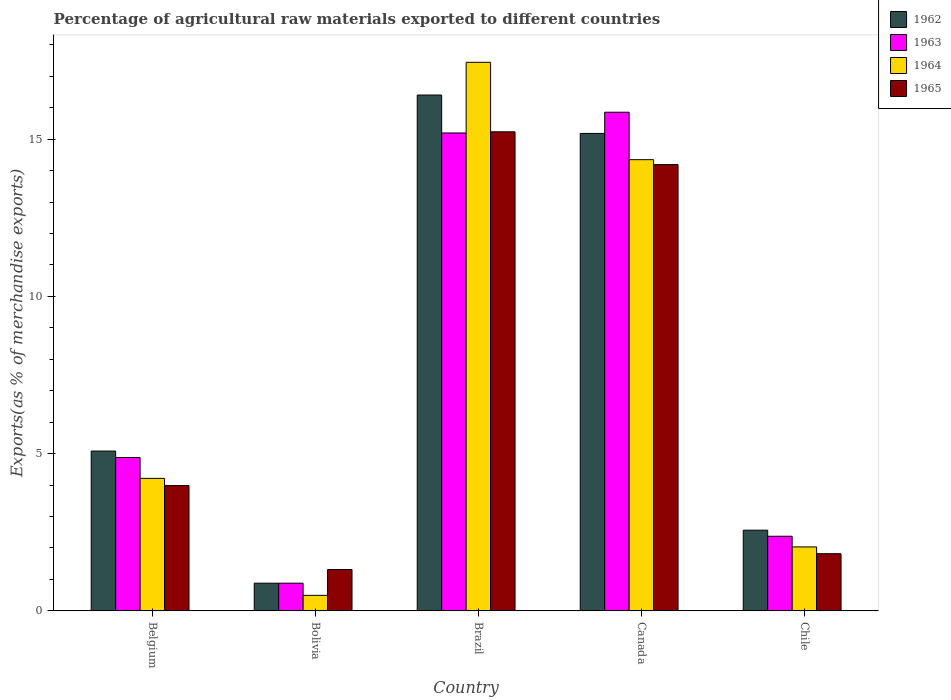How many groups of bars are there?
Provide a succinct answer. 5. Are the number of bars on each tick of the X-axis equal?
Offer a terse response. Yes. How many bars are there on the 3rd tick from the left?
Keep it short and to the point. 4. What is the percentage of exports to different countries in 1962 in Canada?
Keep it short and to the point. 15.18. Across all countries, what is the maximum percentage of exports to different countries in 1963?
Keep it short and to the point. 15.85. Across all countries, what is the minimum percentage of exports to different countries in 1964?
Your response must be concise. 0.49. In which country was the percentage of exports to different countries in 1962 maximum?
Offer a terse response. Brazil. What is the total percentage of exports to different countries in 1962 in the graph?
Make the answer very short. 40.11. What is the difference between the percentage of exports to different countries in 1963 in Belgium and that in Chile?
Your answer should be very brief. 2.5. What is the difference between the percentage of exports to different countries in 1963 in Bolivia and the percentage of exports to different countries in 1962 in Brazil?
Provide a short and direct response. -15.52. What is the average percentage of exports to different countries in 1964 per country?
Make the answer very short. 7.71. What is the difference between the percentage of exports to different countries of/in 1962 and percentage of exports to different countries of/in 1965 in Bolivia?
Your answer should be very brief. -0.43. What is the ratio of the percentage of exports to different countries in 1963 in Bolivia to that in Brazil?
Provide a succinct answer. 0.06. Is the percentage of exports to different countries in 1963 in Belgium less than that in Brazil?
Your answer should be very brief. Yes. Is the difference between the percentage of exports to different countries in 1962 in Bolivia and Canada greater than the difference between the percentage of exports to different countries in 1965 in Bolivia and Canada?
Offer a very short reply. No. What is the difference between the highest and the second highest percentage of exports to different countries in 1963?
Give a very brief answer. 10.32. What is the difference between the highest and the lowest percentage of exports to different countries in 1962?
Your response must be concise. 15.52. Is the sum of the percentage of exports to different countries in 1962 in Canada and Chile greater than the maximum percentage of exports to different countries in 1963 across all countries?
Offer a terse response. Yes. Is it the case that in every country, the sum of the percentage of exports to different countries in 1963 and percentage of exports to different countries in 1962 is greater than the sum of percentage of exports to different countries in 1964 and percentage of exports to different countries in 1965?
Offer a very short reply. No. What does the 2nd bar from the left in Brazil represents?
Offer a very short reply. 1963. How many bars are there?
Offer a very short reply. 20. What is the difference between two consecutive major ticks on the Y-axis?
Keep it short and to the point. 5. Are the values on the major ticks of Y-axis written in scientific E-notation?
Offer a terse response. No. Does the graph contain grids?
Give a very brief answer. No. What is the title of the graph?
Give a very brief answer. Percentage of agricultural raw materials exported to different countries. Does "1973" appear as one of the legend labels in the graph?
Give a very brief answer. No. What is the label or title of the Y-axis?
Offer a terse response. Exports(as % of merchandise exports). What is the Exports(as % of merchandise exports) of 1962 in Belgium?
Keep it short and to the point. 5.08. What is the Exports(as % of merchandise exports) of 1963 in Belgium?
Offer a very short reply. 4.88. What is the Exports(as % of merchandise exports) in 1964 in Belgium?
Your answer should be very brief. 4.21. What is the Exports(as % of merchandise exports) in 1965 in Belgium?
Ensure brevity in your answer.  3.98. What is the Exports(as % of merchandise exports) in 1962 in Bolivia?
Ensure brevity in your answer.  0.88. What is the Exports(as % of merchandise exports) in 1963 in Bolivia?
Your response must be concise. 0.88. What is the Exports(as % of merchandise exports) of 1964 in Bolivia?
Provide a short and direct response. 0.49. What is the Exports(as % of merchandise exports) of 1965 in Bolivia?
Provide a short and direct response. 1.32. What is the Exports(as % of merchandise exports) in 1962 in Brazil?
Make the answer very short. 16.4. What is the Exports(as % of merchandise exports) in 1963 in Brazil?
Offer a terse response. 15.2. What is the Exports(as % of merchandise exports) of 1964 in Brazil?
Ensure brevity in your answer.  17.44. What is the Exports(as % of merchandise exports) in 1965 in Brazil?
Your answer should be compact. 15.23. What is the Exports(as % of merchandise exports) of 1962 in Canada?
Your answer should be compact. 15.18. What is the Exports(as % of merchandise exports) of 1963 in Canada?
Offer a terse response. 15.85. What is the Exports(as % of merchandise exports) of 1964 in Canada?
Your response must be concise. 14.35. What is the Exports(as % of merchandise exports) of 1965 in Canada?
Provide a succinct answer. 14.19. What is the Exports(as % of merchandise exports) in 1962 in Chile?
Your answer should be compact. 2.57. What is the Exports(as % of merchandise exports) in 1963 in Chile?
Provide a succinct answer. 2.37. What is the Exports(as % of merchandise exports) of 1964 in Chile?
Offer a terse response. 2.03. What is the Exports(as % of merchandise exports) of 1965 in Chile?
Provide a succinct answer. 1.82. Across all countries, what is the maximum Exports(as % of merchandise exports) in 1962?
Give a very brief answer. 16.4. Across all countries, what is the maximum Exports(as % of merchandise exports) of 1963?
Your answer should be very brief. 15.85. Across all countries, what is the maximum Exports(as % of merchandise exports) in 1964?
Your answer should be very brief. 17.44. Across all countries, what is the maximum Exports(as % of merchandise exports) of 1965?
Offer a terse response. 15.23. Across all countries, what is the minimum Exports(as % of merchandise exports) in 1962?
Provide a short and direct response. 0.88. Across all countries, what is the minimum Exports(as % of merchandise exports) of 1963?
Give a very brief answer. 0.88. Across all countries, what is the minimum Exports(as % of merchandise exports) of 1964?
Your answer should be compact. 0.49. Across all countries, what is the minimum Exports(as % of merchandise exports) of 1965?
Offer a very short reply. 1.32. What is the total Exports(as % of merchandise exports) in 1962 in the graph?
Offer a very short reply. 40.11. What is the total Exports(as % of merchandise exports) in 1963 in the graph?
Offer a terse response. 39.18. What is the total Exports(as % of merchandise exports) in 1964 in the graph?
Offer a terse response. 38.53. What is the total Exports(as % of merchandise exports) in 1965 in the graph?
Offer a terse response. 36.54. What is the difference between the Exports(as % of merchandise exports) in 1962 in Belgium and that in Bolivia?
Provide a short and direct response. 4.2. What is the difference between the Exports(as % of merchandise exports) of 1963 in Belgium and that in Bolivia?
Keep it short and to the point. 4. What is the difference between the Exports(as % of merchandise exports) in 1964 in Belgium and that in Bolivia?
Offer a terse response. 3.72. What is the difference between the Exports(as % of merchandise exports) in 1965 in Belgium and that in Bolivia?
Your answer should be compact. 2.67. What is the difference between the Exports(as % of merchandise exports) in 1962 in Belgium and that in Brazil?
Make the answer very short. -11.32. What is the difference between the Exports(as % of merchandise exports) in 1963 in Belgium and that in Brazil?
Give a very brief answer. -10.32. What is the difference between the Exports(as % of merchandise exports) of 1964 in Belgium and that in Brazil?
Your answer should be very brief. -13.23. What is the difference between the Exports(as % of merchandise exports) of 1965 in Belgium and that in Brazil?
Offer a very short reply. -11.25. What is the difference between the Exports(as % of merchandise exports) of 1962 in Belgium and that in Canada?
Offer a very short reply. -10.1. What is the difference between the Exports(as % of merchandise exports) in 1963 in Belgium and that in Canada?
Offer a very short reply. -10.98. What is the difference between the Exports(as % of merchandise exports) in 1964 in Belgium and that in Canada?
Your answer should be very brief. -10.13. What is the difference between the Exports(as % of merchandise exports) of 1965 in Belgium and that in Canada?
Offer a very short reply. -10.21. What is the difference between the Exports(as % of merchandise exports) in 1962 in Belgium and that in Chile?
Offer a terse response. 2.52. What is the difference between the Exports(as % of merchandise exports) in 1963 in Belgium and that in Chile?
Offer a very short reply. 2.5. What is the difference between the Exports(as % of merchandise exports) of 1964 in Belgium and that in Chile?
Provide a short and direct response. 2.18. What is the difference between the Exports(as % of merchandise exports) of 1965 in Belgium and that in Chile?
Provide a succinct answer. 2.17. What is the difference between the Exports(as % of merchandise exports) of 1962 in Bolivia and that in Brazil?
Your response must be concise. -15.52. What is the difference between the Exports(as % of merchandise exports) in 1963 in Bolivia and that in Brazil?
Your answer should be very brief. -14.31. What is the difference between the Exports(as % of merchandise exports) of 1964 in Bolivia and that in Brazil?
Provide a succinct answer. -16.95. What is the difference between the Exports(as % of merchandise exports) in 1965 in Bolivia and that in Brazil?
Make the answer very short. -13.92. What is the difference between the Exports(as % of merchandise exports) in 1962 in Bolivia and that in Canada?
Ensure brevity in your answer.  -14.3. What is the difference between the Exports(as % of merchandise exports) of 1963 in Bolivia and that in Canada?
Ensure brevity in your answer.  -14.97. What is the difference between the Exports(as % of merchandise exports) in 1964 in Bolivia and that in Canada?
Give a very brief answer. -13.85. What is the difference between the Exports(as % of merchandise exports) in 1965 in Bolivia and that in Canada?
Keep it short and to the point. -12.87. What is the difference between the Exports(as % of merchandise exports) in 1962 in Bolivia and that in Chile?
Provide a short and direct response. -1.69. What is the difference between the Exports(as % of merchandise exports) in 1963 in Bolivia and that in Chile?
Offer a very short reply. -1.49. What is the difference between the Exports(as % of merchandise exports) of 1964 in Bolivia and that in Chile?
Keep it short and to the point. -1.54. What is the difference between the Exports(as % of merchandise exports) of 1965 in Bolivia and that in Chile?
Your response must be concise. -0.5. What is the difference between the Exports(as % of merchandise exports) of 1962 in Brazil and that in Canada?
Keep it short and to the point. 1.22. What is the difference between the Exports(as % of merchandise exports) of 1963 in Brazil and that in Canada?
Your response must be concise. -0.66. What is the difference between the Exports(as % of merchandise exports) of 1964 in Brazil and that in Canada?
Offer a very short reply. 3.1. What is the difference between the Exports(as % of merchandise exports) of 1965 in Brazil and that in Canada?
Provide a succinct answer. 1.04. What is the difference between the Exports(as % of merchandise exports) of 1962 in Brazil and that in Chile?
Offer a very short reply. 13.84. What is the difference between the Exports(as % of merchandise exports) of 1963 in Brazil and that in Chile?
Make the answer very short. 12.82. What is the difference between the Exports(as % of merchandise exports) in 1964 in Brazil and that in Chile?
Keep it short and to the point. 15.41. What is the difference between the Exports(as % of merchandise exports) of 1965 in Brazil and that in Chile?
Provide a short and direct response. 13.41. What is the difference between the Exports(as % of merchandise exports) of 1962 in Canada and that in Chile?
Your answer should be very brief. 12.61. What is the difference between the Exports(as % of merchandise exports) of 1963 in Canada and that in Chile?
Your answer should be very brief. 13.48. What is the difference between the Exports(as % of merchandise exports) of 1964 in Canada and that in Chile?
Provide a succinct answer. 12.31. What is the difference between the Exports(as % of merchandise exports) in 1965 in Canada and that in Chile?
Ensure brevity in your answer.  12.37. What is the difference between the Exports(as % of merchandise exports) in 1962 in Belgium and the Exports(as % of merchandise exports) in 1963 in Bolivia?
Provide a succinct answer. 4.2. What is the difference between the Exports(as % of merchandise exports) in 1962 in Belgium and the Exports(as % of merchandise exports) in 1964 in Bolivia?
Your response must be concise. 4.59. What is the difference between the Exports(as % of merchandise exports) in 1962 in Belgium and the Exports(as % of merchandise exports) in 1965 in Bolivia?
Offer a terse response. 3.77. What is the difference between the Exports(as % of merchandise exports) of 1963 in Belgium and the Exports(as % of merchandise exports) of 1964 in Bolivia?
Keep it short and to the point. 4.38. What is the difference between the Exports(as % of merchandise exports) of 1963 in Belgium and the Exports(as % of merchandise exports) of 1965 in Bolivia?
Make the answer very short. 3.56. What is the difference between the Exports(as % of merchandise exports) in 1964 in Belgium and the Exports(as % of merchandise exports) in 1965 in Bolivia?
Give a very brief answer. 2.9. What is the difference between the Exports(as % of merchandise exports) of 1962 in Belgium and the Exports(as % of merchandise exports) of 1963 in Brazil?
Make the answer very short. -10.11. What is the difference between the Exports(as % of merchandise exports) in 1962 in Belgium and the Exports(as % of merchandise exports) in 1964 in Brazil?
Provide a succinct answer. -12.36. What is the difference between the Exports(as % of merchandise exports) of 1962 in Belgium and the Exports(as % of merchandise exports) of 1965 in Brazil?
Offer a terse response. -10.15. What is the difference between the Exports(as % of merchandise exports) of 1963 in Belgium and the Exports(as % of merchandise exports) of 1964 in Brazil?
Offer a very short reply. -12.56. What is the difference between the Exports(as % of merchandise exports) in 1963 in Belgium and the Exports(as % of merchandise exports) in 1965 in Brazil?
Ensure brevity in your answer.  -10.35. What is the difference between the Exports(as % of merchandise exports) of 1964 in Belgium and the Exports(as % of merchandise exports) of 1965 in Brazil?
Offer a very short reply. -11.02. What is the difference between the Exports(as % of merchandise exports) of 1962 in Belgium and the Exports(as % of merchandise exports) of 1963 in Canada?
Your answer should be very brief. -10.77. What is the difference between the Exports(as % of merchandise exports) in 1962 in Belgium and the Exports(as % of merchandise exports) in 1964 in Canada?
Give a very brief answer. -9.26. What is the difference between the Exports(as % of merchandise exports) in 1962 in Belgium and the Exports(as % of merchandise exports) in 1965 in Canada?
Make the answer very short. -9.11. What is the difference between the Exports(as % of merchandise exports) in 1963 in Belgium and the Exports(as % of merchandise exports) in 1964 in Canada?
Keep it short and to the point. -9.47. What is the difference between the Exports(as % of merchandise exports) in 1963 in Belgium and the Exports(as % of merchandise exports) in 1965 in Canada?
Your answer should be very brief. -9.31. What is the difference between the Exports(as % of merchandise exports) of 1964 in Belgium and the Exports(as % of merchandise exports) of 1965 in Canada?
Keep it short and to the point. -9.98. What is the difference between the Exports(as % of merchandise exports) in 1962 in Belgium and the Exports(as % of merchandise exports) in 1963 in Chile?
Your response must be concise. 2.71. What is the difference between the Exports(as % of merchandise exports) of 1962 in Belgium and the Exports(as % of merchandise exports) of 1964 in Chile?
Give a very brief answer. 3.05. What is the difference between the Exports(as % of merchandise exports) in 1962 in Belgium and the Exports(as % of merchandise exports) in 1965 in Chile?
Give a very brief answer. 3.26. What is the difference between the Exports(as % of merchandise exports) of 1963 in Belgium and the Exports(as % of merchandise exports) of 1964 in Chile?
Provide a short and direct response. 2.84. What is the difference between the Exports(as % of merchandise exports) of 1963 in Belgium and the Exports(as % of merchandise exports) of 1965 in Chile?
Ensure brevity in your answer.  3.06. What is the difference between the Exports(as % of merchandise exports) in 1964 in Belgium and the Exports(as % of merchandise exports) in 1965 in Chile?
Make the answer very short. 2.4. What is the difference between the Exports(as % of merchandise exports) in 1962 in Bolivia and the Exports(as % of merchandise exports) in 1963 in Brazil?
Ensure brevity in your answer.  -14.31. What is the difference between the Exports(as % of merchandise exports) of 1962 in Bolivia and the Exports(as % of merchandise exports) of 1964 in Brazil?
Your response must be concise. -16.56. What is the difference between the Exports(as % of merchandise exports) of 1962 in Bolivia and the Exports(as % of merchandise exports) of 1965 in Brazil?
Provide a succinct answer. -14.35. What is the difference between the Exports(as % of merchandise exports) in 1963 in Bolivia and the Exports(as % of merchandise exports) in 1964 in Brazil?
Provide a succinct answer. -16.56. What is the difference between the Exports(as % of merchandise exports) in 1963 in Bolivia and the Exports(as % of merchandise exports) in 1965 in Brazil?
Your answer should be very brief. -14.35. What is the difference between the Exports(as % of merchandise exports) in 1964 in Bolivia and the Exports(as % of merchandise exports) in 1965 in Brazil?
Keep it short and to the point. -14.74. What is the difference between the Exports(as % of merchandise exports) in 1962 in Bolivia and the Exports(as % of merchandise exports) in 1963 in Canada?
Keep it short and to the point. -14.97. What is the difference between the Exports(as % of merchandise exports) of 1962 in Bolivia and the Exports(as % of merchandise exports) of 1964 in Canada?
Provide a succinct answer. -13.46. What is the difference between the Exports(as % of merchandise exports) of 1962 in Bolivia and the Exports(as % of merchandise exports) of 1965 in Canada?
Offer a terse response. -13.31. What is the difference between the Exports(as % of merchandise exports) of 1963 in Bolivia and the Exports(as % of merchandise exports) of 1964 in Canada?
Your answer should be very brief. -13.46. What is the difference between the Exports(as % of merchandise exports) of 1963 in Bolivia and the Exports(as % of merchandise exports) of 1965 in Canada?
Ensure brevity in your answer.  -13.31. What is the difference between the Exports(as % of merchandise exports) of 1964 in Bolivia and the Exports(as % of merchandise exports) of 1965 in Canada?
Your answer should be very brief. -13.7. What is the difference between the Exports(as % of merchandise exports) of 1962 in Bolivia and the Exports(as % of merchandise exports) of 1963 in Chile?
Provide a short and direct response. -1.49. What is the difference between the Exports(as % of merchandise exports) in 1962 in Bolivia and the Exports(as % of merchandise exports) in 1964 in Chile?
Make the answer very short. -1.15. What is the difference between the Exports(as % of merchandise exports) in 1962 in Bolivia and the Exports(as % of merchandise exports) in 1965 in Chile?
Your response must be concise. -0.94. What is the difference between the Exports(as % of merchandise exports) in 1963 in Bolivia and the Exports(as % of merchandise exports) in 1964 in Chile?
Make the answer very short. -1.15. What is the difference between the Exports(as % of merchandise exports) in 1963 in Bolivia and the Exports(as % of merchandise exports) in 1965 in Chile?
Provide a succinct answer. -0.94. What is the difference between the Exports(as % of merchandise exports) in 1964 in Bolivia and the Exports(as % of merchandise exports) in 1965 in Chile?
Provide a succinct answer. -1.32. What is the difference between the Exports(as % of merchandise exports) of 1962 in Brazil and the Exports(as % of merchandise exports) of 1963 in Canada?
Your response must be concise. 0.55. What is the difference between the Exports(as % of merchandise exports) in 1962 in Brazil and the Exports(as % of merchandise exports) in 1964 in Canada?
Ensure brevity in your answer.  2.06. What is the difference between the Exports(as % of merchandise exports) in 1962 in Brazil and the Exports(as % of merchandise exports) in 1965 in Canada?
Ensure brevity in your answer.  2.21. What is the difference between the Exports(as % of merchandise exports) in 1963 in Brazil and the Exports(as % of merchandise exports) in 1964 in Canada?
Your answer should be compact. 0.85. What is the difference between the Exports(as % of merchandise exports) in 1963 in Brazil and the Exports(as % of merchandise exports) in 1965 in Canada?
Offer a terse response. 1.01. What is the difference between the Exports(as % of merchandise exports) of 1964 in Brazil and the Exports(as % of merchandise exports) of 1965 in Canada?
Your answer should be very brief. 3.25. What is the difference between the Exports(as % of merchandise exports) in 1962 in Brazil and the Exports(as % of merchandise exports) in 1963 in Chile?
Provide a short and direct response. 14.03. What is the difference between the Exports(as % of merchandise exports) of 1962 in Brazil and the Exports(as % of merchandise exports) of 1964 in Chile?
Provide a succinct answer. 14.37. What is the difference between the Exports(as % of merchandise exports) of 1962 in Brazil and the Exports(as % of merchandise exports) of 1965 in Chile?
Offer a very short reply. 14.58. What is the difference between the Exports(as % of merchandise exports) of 1963 in Brazil and the Exports(as % of merchandise exports) of 1964 in Chile?
Your response must be concise. 13.16. What is the difference between the Exports(as % of merchandise exports) of 1963 in Brazil and the Exports(as % of merchandise exports) of 1965 in Chile?
Your response must be concise. 13.38. What is the difference between the Exports(as % of merchandise exports) of 1964 in Brazil and the Exports(as % of merchandise exports) of 1965 in Chile?
Your answer should be very brief. 15.62. What is the difference between the Exports(as % of merchandise exports) of 1962 in Canada and the Exports(as % of merchandise exports) of 1963 in Chile?
Your answer should be compact. 12.81. What is the difference between the Exports(as % of merchandise exports) in 1962 in Canada and the Exports(as % of merchandise exports) in 1964 in Chile?
Ensure brevity in your answer.  13.15. What is the difference between the Exports(as % of merchandise exports) of 1962 in Canada and the Exports(as % of merchandise exports) of 1965 in Chile?
Provide a short and direct response. 13.36. What is the difference between the Exports(as % of merchandise exports) of 1963 in Canada and the Exports(as % of merchandise exports) of 1964 in Chile?
Ensure brevity in your answer.  13.82. What is the difference between the Exports(as % of merchandise exports) in 1963 in Canada and the Exports(as % of merchandise exports) in 1965 in Chile?
Ensure brevity in your answer.  14.04. What is the difference between the Exports(as % of merchandise exports) in 1964 in Canada and the Exports(as % of merchandise exports) in 1965 in Chile?
Offer a very short reply. 12.53. What is the average Exports(as % of merchandise exports) of 1962 per country?
Make the answer very short. 8.02. What is the average Exports(as % of merchandise exports) in 1963 per country?
Make the answer very short. 7.84. What is the average Exports(as % of merchandise exports) in 1964 per country?
Your response must be concise. 7.71. What is the average Exports(as % of merchandise exports) in 1965 per country?
Keep it short and to the point. 7.31. What is the difference between the Exports(as % of merchandise exports) in 1962 and Exports(as % of merchandise exports) in 1963 in Belgium?
Keep it short and to the point. 0.2. What is the difference between the Exports(as % of merchandise exports) in 1962 and Exports(as % of merchandise exports) in 1964 in Belgium?
Ensure brevity in your answer.  0.87. What is the difference between the Exports(as % of merchandise exports) of 1962 and Exports(as % of merchandise exports) of 1965 in Belgium?
Offer a terse response. 1.1. What is the difference between the Exports(as % of merchandise exports) of 1963 and Exports(as % of merchandise exports) of 1964 in Belgium?
Make the answer very short. 0.66. What is the difference between the Exports(as % of merchandise exports) in 1963 and Exports(as % of merchandise exports) in 1965 in Belgium?
Offer a terse response. 0.89. What is the difference between the Exports(as % of merchandise exports) of 1964 and Exports(as % of merchandise exports) of 1965 in Belgium?
Provide a succinct answer. 0.23. What is the difference between the Exports(as % of merchandise exports) in 1962 and Exports(as % of merchandise exports) in 1963 in Bolivia?
Your response must be concise. 0. What is the difference between the Exports(as % of merchandise exports) of 1962 and Exports(as % of merchandise exports) of 1964 in Bolivia?
Your response must be concise. 0.39. What is the difference between the Exports(as % of merchandise exports) in 1962 and Exports(as % of merchandise exports) in 1965 in Bolivia?
Make the answer very short. -0.43. What is the difference between the Exports(as % of merchandise exports) of 1963 and Exports(as % of merchandise exports) of 1964 in Bolivia?
Offer a very short reply. 0.39. What is the difference between the Exports(as % of merchandise exports) in 1963 and Exports(as % of merchandise exports) in 1965 in Bolivia?
Offer a terse response. -0.43. What is the difference between the Exports(as % of merchandise exports) of 1964 and Exports(as % of merchandise exports) of 1965 in Bolivia?
Keep it short and to the point. -0.82. What is the difference between the Exports(as % of merchandise exports) in 1962 and Exports(as % of merchandise exports) in 1963 in Brazil?
Your response must be concise. 1.21. What is the difference between the Exports(as % of merchandise exports) in 1962 and Exports(as % of merchandise exports) in 1964 in Brazil?
Your response must be concise. -1.04. What is the difference between the Exports(as % of merchandise exports) in 1962 and Exports(as % of merchandise exports) in 1965 in Brazil?
Ensure brevity in your answer.  1.17. What is the difference between the Exports(as % of merchandise exports) in 1963 and Exports(as % of merchandise exports) in 1964 in Brazil?
Provide a short and direct response. -2.25. What is the difference between the Exports(as % of merchandise exports) of 1963 and Exports(as % of merchandise exports) of 1965 in Brazil?
Offer a very short reply. -0.04. What is the difference between the Exports(as % of merchandise exports) of 1964 and Exports(as % of merchandise exports) of 1965 in Brazil?
Your response must be concise. 2.21. What is the difference between the Exports(as % of merchandise exports) of 1962 and Exports(as % of merchandise exports) of 1963 in Canada?
Give a very brief answer. -0.67. What is the difference between the Exports(as % of merchandise exports) of 1962 and Exports(as % of merchandise exports) of 1964 in Canada?
Offer a terse response. 0.83. What is the difference between the Exports(as % of merchandise exports) of 1963 and Exports(as % of merchandise exports) of 1964 in Canada?
Provide a short and direct response. 1.51. What is the difference between the Exports(as % of merchandise exports) in 1963 and Exports(as % of merchandise exports) in 1965 in Canada?
Provide a short and direct response. 1.67. What is the difference between the Exports(as % of merchandise exports) of 1964 and Exports(as % of merchandise exports) of 1965 in Canada?
Offer a very short reply. 0.16. What is the difference between the Exports(as % of merchandise exports) of 1962 and Exports(as % of merchandise exports) of 1963 in Chile?
Your answer should be very brief. 0.19. What is the difference between the Exports(as % of merchandise exports) in 1962 and Exports(as % of merchandise exports) in 1964 in Chile?
Provide a succinct answer. 0.53. What is the difference between the Exports(as % of merchandise exports) of 1962 and Exports(as % of merchandise exports) of 1965 in Chile?
Ensure brevity in your answer.  0.75. What is the difference between the Exports(as % of merchandise exports) in 1963 and Exports(as % of merchandise exports) in 1964 in Chile?
Your answer should be very brief. 0.34. What is the difference between the Exports(as % of merchandise exports) in 1963 and Exports(as % of merchandise exports) in 1965 in Chile?
Offer a very short reply. 0.55. What is the difference between the Exports(as % of merchandise exports) of 1964 and Exports(as % of merchandise exports) of 1965 in Chile?
Keep it short and to the point. 0.22. What is the ratio of the Exports(as % of merchandise exports) in 1962 in Belgium to that in Bolivia?
Provide a short and direct response. 5.77. What is the ratio of the Exports(as % of merchandise exports) of 1963 in Belgium to that in Bolivia?
Make the answer very short. 5.53. What is the ratio of the Exports(as % of merchandise exports) in 1964 in Belgium to that in Bolivia?
Make the answer very short. 8.52. What is the ratio of the Exports(as % of merchandise exports) in 1965 in Belgium to that in Bolivia?
Your response must be concise. 3.03. What is the ratio of the Exports(as % of merchandise exports) of 1962 in Belgium to that in Brazil?
Offer a terse response. 0.31. What is the ratio of the Exports(as % of merchandise exports) of 1963 in Belgium to that in Brazil?
Your response must be concise. 0.32. What is the ratio of the Exports(as % of merchandise exports) of 1964 in Belgium to that in Brazil?
Give a very brief answer. 0.24. What is the ratio of the Exports(as % of merchandise exports) in 1965 in Belgium to that in Brazil?
Keep it short and to the point. 0.26. What is the ratio of the Exports(as % of merchandise exports) in 1962 in Belgium to that in Canada?
Provide a succinct answer. 0.33. What is the ratio of the Exports(as % of merchandise exports) of 1963 in Belgium to that in Canada?
Your answer should be very brief. 0.31. What is the ratio of the Exports(as % of merchandise exports) of 1964 in Belgium to that in Canada?
Keep it short and to the point. 0.29. What is the ratio of the Exports(as % of merchandise exports) of 1965 in Belgium to that in Canada?
Offer a very short reply. 0.28. What is the ratio of the Exports(as % of merchandise exports) of 1962 in Belgium to that in Chile?
Provide a short and direct response. 1.98. What is the ratio of the Exports(as % of merchandise exports) in 1963 in Belgium to that in Chile?
Keep it short and to the point. 2.06. What is the ratio of the Exports(as % of merchandise exports) of 1964 in Belgium to that in Chile?
Offer a terse response. 2.07. What is the ratio of the Exports(as % of merchandise exports) in 1965 in Belgium to that in Chile?
Provide a short and direct response. 2.19. What is the ratio of the Exports(as % of merchandise exports) of 1962 in Bolivia to that in Brazil?
Make the answer very short. 0.05. What is the ratio of the Exports(as % of merchandise exports) in 1963 in Bolivia to that in Brazil?
Your answer should be very brief. 0.06. What is the ratio of the Exports(as % of merchandise exports) in 1964 in Bolivia to that in Brazil?
Provide a succinct answer. 0.03. What is the ratio of the Exports(as % of merchandise exports) of 1965 in Bolivia to that in Brazil?
Your response must be concise. 0.09. What is the ratio of the Exports(as % of merchandise exports) in 1962 in Bolivia to that in Canada?
Make the answer very short. 0.06. What is the ratio of the Exports(as % of merchandise exports) in 1963 in Bolivia to that in Canada?
Your response must be concise. 0.06. What is the ratio of the Exports(as % of merchandise exports) of 1964 in Bolivia to that in Canada?
Make the answer very short. 0.03. What is the ratio of the Exports(as % of merchandise exports) in 1965 in Bolivia to that in Canada?
Provide a short and direct response. 0.09. What is the ratio of the Exports(as % of merchandise exports) in 1962 in Bolivia to that in Chile?
Your response must be concise. 0.34. What is the ratio of the Exports(as % of merchandise exports) in 1963 in Bolivia to that in Chile?
Provide a succinct answer. 0.37. What is the ratio of the Exports(as % of merchandise exports) in 1964 in Bolivia to that in Chile?
Offer a very short reply. 0.24. What is the ratio of the Exports(as % of merchandise exports) in 1965 in Bolivia to that in Chile?
Your answer should be compact. 0.72. What is the ratio of the Exports(as % of merchandise exports) in 1962 in Brazil to that in Canada?
Ensure brevity in your answer.  1.08. What is the ratio of the Exports(as % of merchandise exports) in 1963 in Brazil to that in Canada?
Your response must be concise. 0.96. What is the ratio of the Exports(as % of merchandise exports) in 1964 in Brazil to that in Canada?
Offer a terse response. 1.22. What is the ratio of the Exports(as % of merchandise exports) in 1965 in Brazil to that in Canada?
Offer a very short reply. 1.07. What is the ratio of the Exports(as % of merchandise exports) in 1962 in Brazil to that in Chile?
Provide a short and direct response. 6.39. What is the ratio of the Exports(as % of merchandise exports) of 1963 in Brazil to that in Chile?
Keep it short and to the point. 6.4. What is the ratio of the Exports(as % of merchandise exports) in 1964 in Brazil to that in Chile?
Provide a short and direct response. 8.57. What is the ratio of the Exports(as % of merchandise exports) in 1965 in Brazil to that in Chile?
Make the answer very short. 8.38. What is the ratio of the Exports(as % of merchandise exports) in 1962 in Canada to that in Chile?
Your answer should be compact. 5.91. What is the ratio of the Exports(as % of merchandise exports) of 1963 in Canada to that in Chile?
Your response must be concise. 6.68. What is the ratio of the Exports(as % of merchandise exports) in 1964 in Canada to that in Chile?
Your response must be concise. 7.05. What is the ratio of the Exports(as % of merchandise exports) of 1965 in Canada to that in Chile?
Offer a terse response. 7.8. What is the difference between the highest and the second highest Exports(as % of merchandise exports) of 1962?
Your answer should be very brief. 1.22. What is the difference between the highest and the second highest Exports(as % of merchandise exports) in 1963?
Your response must be concise. 0.66. What is the difference between the highest and the second highest Exports(as % of merchandise exports) in 1964?
Provide a short and direct response. 3.1. What is the difference between the highest and the second highest Exports(as % of merchandise exports) in 1965?
Give a very brief answer. 1.04. What is the difference between the highest and the lowest Exports(as % of merchandise exports) in 1962?
Provide a short and direct response. 15.52. What is the difference between the highest and the lowest Exports(as % of merchandise exports) in 1963?
Your answer should be compact. 14.97. What is the difference between the highest and the lowest Exports(as % of merchandise exports) in 1964?
Give a very brief answer. 16.95. What is the difference between the highest and the lowest Exports(as % of merchandise exports) in 1965?
Provide a succinct answer. 13.92. 